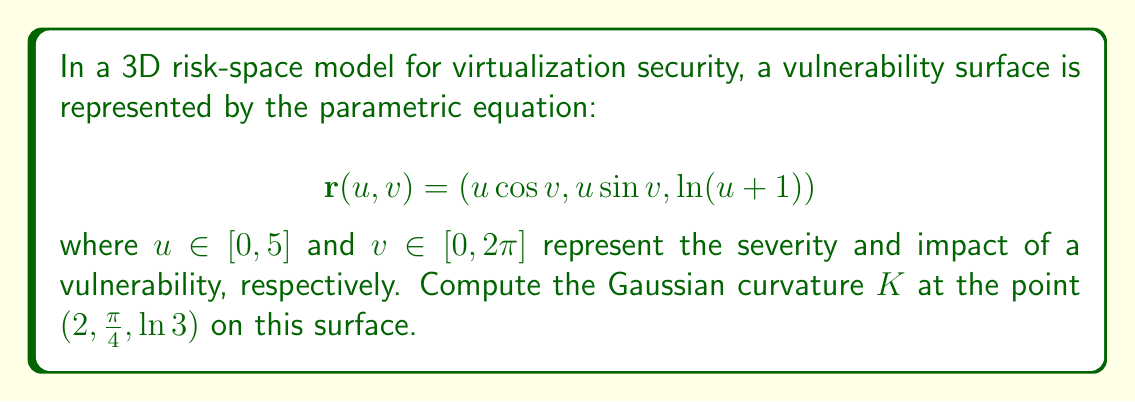Provide a solution to this math problem. To compute the Gaussian curvature, we need to follow these steps:

1) First, calculate the partial derivatives:
   $$\mathbf{r}_u = (\cos v, \sin v, \frac{1}{u+1})$$
   $$\mathbf{r}_v = (-u\sin v, u\cos v, 0)$$

2) Calculate the second partial derivatives:
   $$\mathbf{r}_{uu} = (0, 0, -\frac{1}{(u+1)^2})$$
   $$\mathbf{r}_{uv} = (-\sin v, \cos v, 0)$$
   $$\mathbf{r}_{vv} = (-u\cos v, -u\sin v, 0)$$

3) Calculate the normal vector:
   $$\mathbf{N} = \frac{\mathbf{r}_u \times \mathbf{r}_v}{|\mathbf{r}_u \times \mathbf{r}_v|}$$
   $$= \frac{(-\frac{u\sin v}{u+1}, -\frac{u\cos v}{u+1}, u)}{\sqrt{u^2 + \frac{u^2}{(u+1)^2}}}$$

4) Calculate the coefficients of the first fundamental form:
   $$E = \mathbf{r}_u \cdot \mathbf{r}_u = 1 + \frac{1}{(u+1)^2}$$
   $$F = \mathbf{r}_u \cdot \mathbf{r}_v = 0$$
   $$G = \mathbf{r}_v \cdot \mathbf{r}_v = u^2$$

5) Calculate the coefficients of the second fundamental form:
   $$L = \mathbf{r}_{uu} \cdot \mathbf{N} = -\frac{1}{(u+1)^2\sqrt{u^2 + \frac{u^2}{(u+1)^2}}}$$
   $$M = \mathbf{r}_{uv} \cdot \mathbf{N} = 0$$
   $$N = \mathbf{r}_{vv} \cdot \mathbf{N} = -\frac{u^2}{\sqrt{u^2 + \frac{u^2}{(u+1)^2}}}$$

6) The Gaussian curvature is given by:
   $$K = \frac{LN - M^2}{EG - F^2}$$

7) Substituting the values at the point $(2,\frac{\pi}{4},\ln 3)$, where $u=2$:
   $$K = \frac{(-\frac{1}{9\sqrt{4 + \frac{4}{9}}})(-\frac{4}{\sqrt{4 + \frac{4}{9}}}) - 0^2}{(1 + \frac{1}{9})(4) - 0^2}$$

8) Simplifying:
   $$K = \frac{4}{81(4 + \frac{4}{9})} \cdot \frac{4}{(\frac{13}{9})}$$
   $$K = \frac{16}{13 \cdot 13} = \frac{16}{169}$$
Answer: The Gaussian curvature at the point $(2,\frac{\pi}{4},\ln 3)$ on the vulnerability surface is $K = \frac{16}{169}$. 